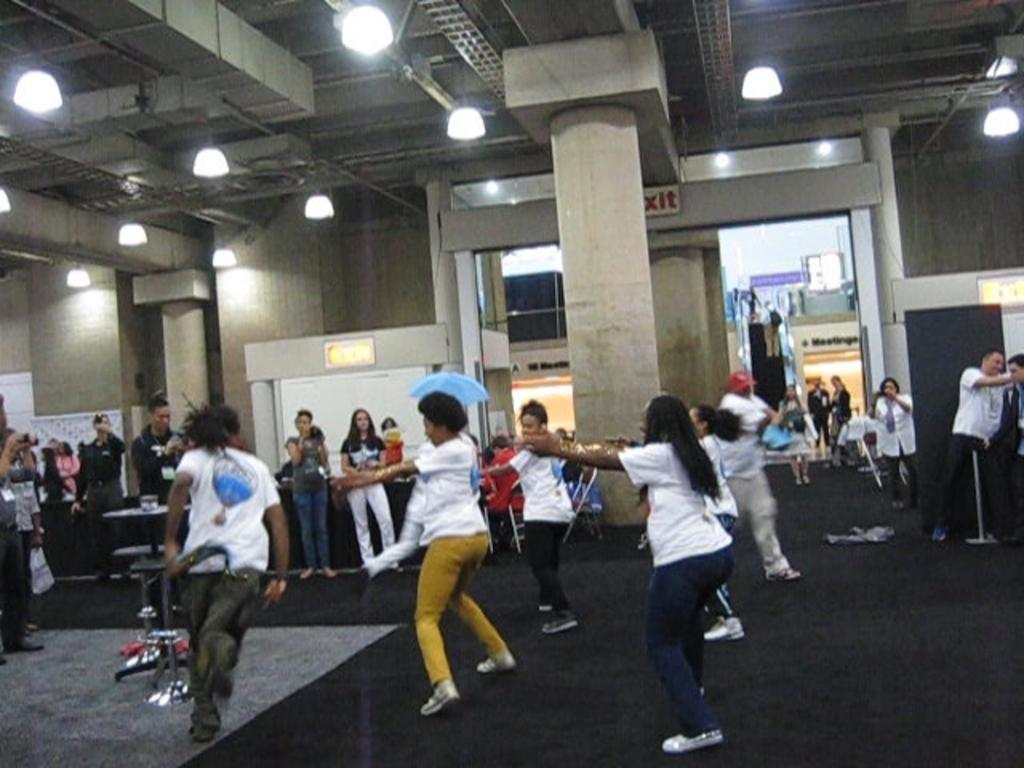How many people are in the image? There are people in the image, but the exact number is not specified. What are some of the people doing in the image? Some people are dancing on the floor. What type of furniture can be seen in the image? There are tables in the image. What architectural elements are present in the image? There are pillars in the image. What type of signage is visible in the image? There are boards and posters in the image. What type of lighting is present in the image? There are lights in the image. What type of structure is present in the image? There is a wall in the image. What type of coat is being worn by the patch on the wall in the image? There is no coat or patch present on the wall in the image. 